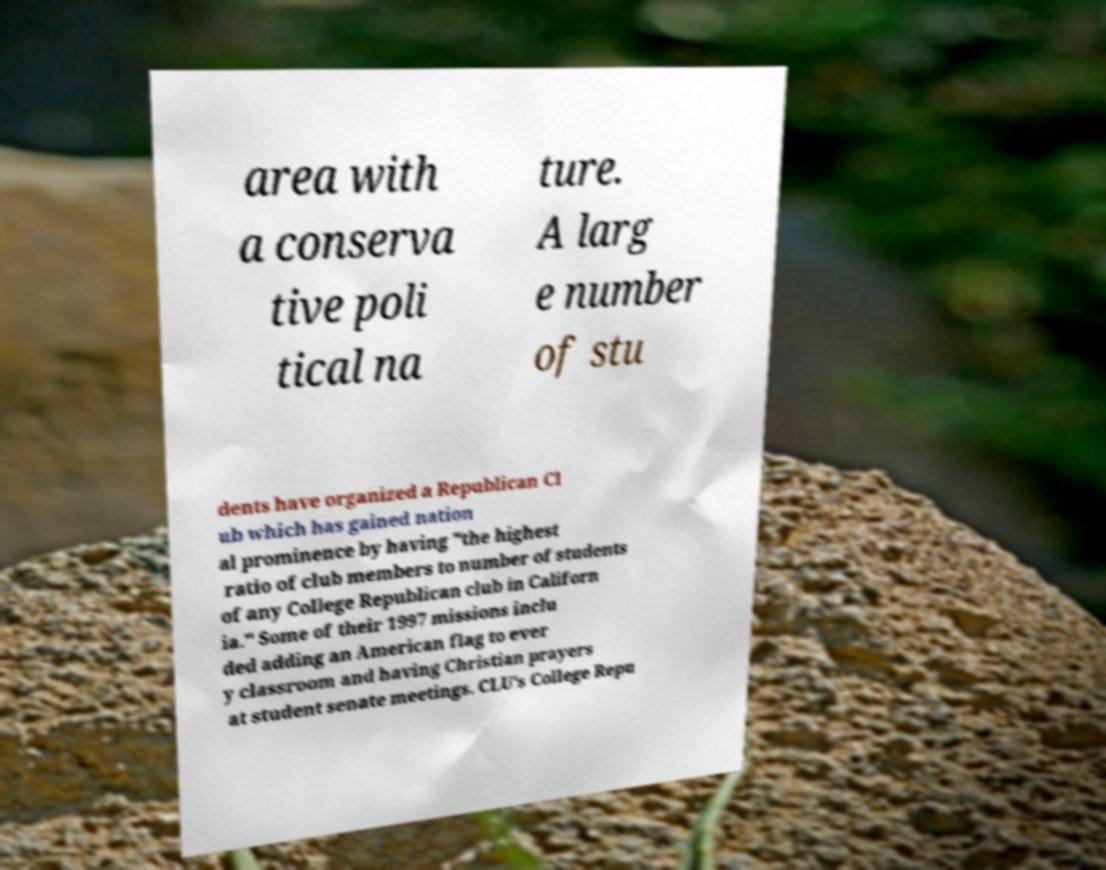There's text embedded in this image that I need extracted. Can you transcribe it verbatim? area with a conserva tive poli tical na ture. A larg e number of stu dents have organized a Republican Cl ub which has gained nation al prominence by having "the highest ratio of club members to number of students of any College Republican club in Californ ia." Some of their 1997 missions inclu ded adding an American flag to ever y classroom and having Christian prayers at student senate meetings. CLU's College Repu 